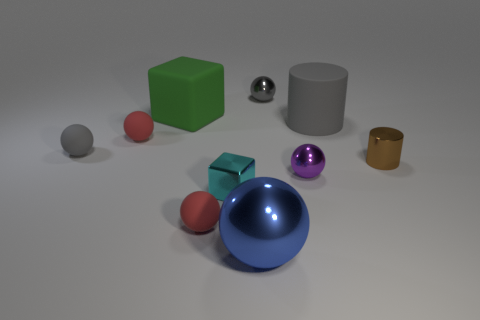How many tiny matte balls are the same color as the large matte cylinder?
Make the answer very short. 1. There is a green cube behind the tiny purple ball; how big is it?
Offer a terse response. Large. How many metallic spheres are the same size as the green cube?
Your response must be concise. 1. The large thing that is made of the same material as the tiny cyan block is what color?
Make the answer very short. Blue. Is the number of purple balls that are behind the tiny gray matte object less than the number of big purple blocks?
Ensure brevity in your answer.  No. The large blue thing that is the same material as the small cyan thing is what shape?
Make the answer very short. Sphere. How many shiny things are red blocks or small purple things?
Ensure brevity in your answer.  1. Are there the same number of big blue metal balls that are in front of the small purple shiny ball and large gray cylinders?
Offer a terse response. Yes. Is the color of the ball behind the large green object the same as the large cylinder?
Your response must be concise. Yes. What material is the gray object that is both in front of the green cube and right of the large green object?
Make the answer very short. Rubber. 